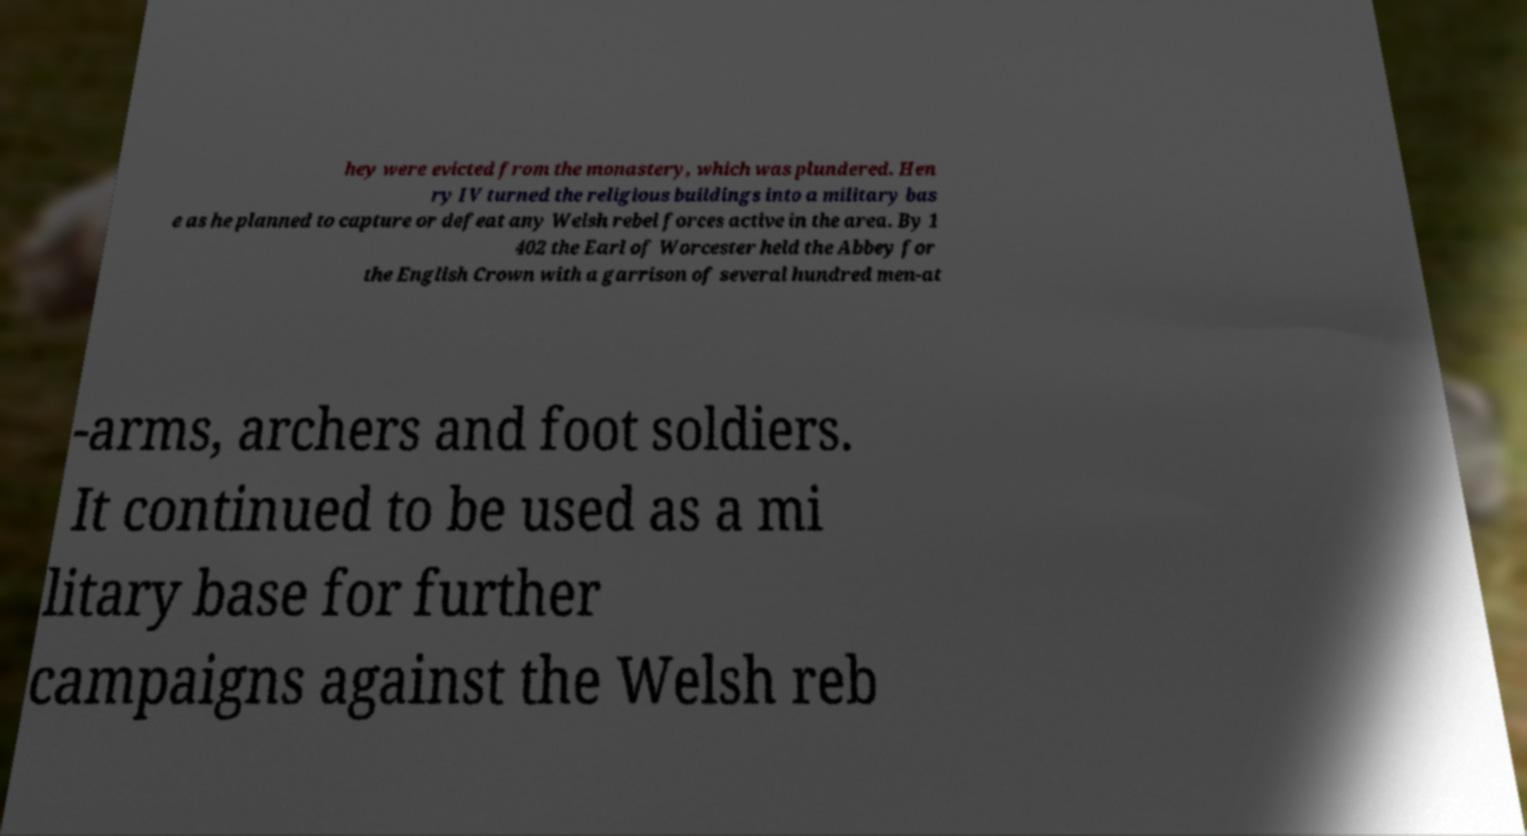Could you extract and type out the text from this image? hey were evicted from the monastery, which was plundered. Hen ry IV turned the religious buildings into a military bas e as he planned to capture or defeat any Welsh rebel forces active in the area. By 1 402 the Earl of Worcester held the Abbey for the English Crown with a garrison of several hundred men-at -arms, archers and foot soldiers. It continued to be used as a mi litary base for further campaigns against the Welsh reb 